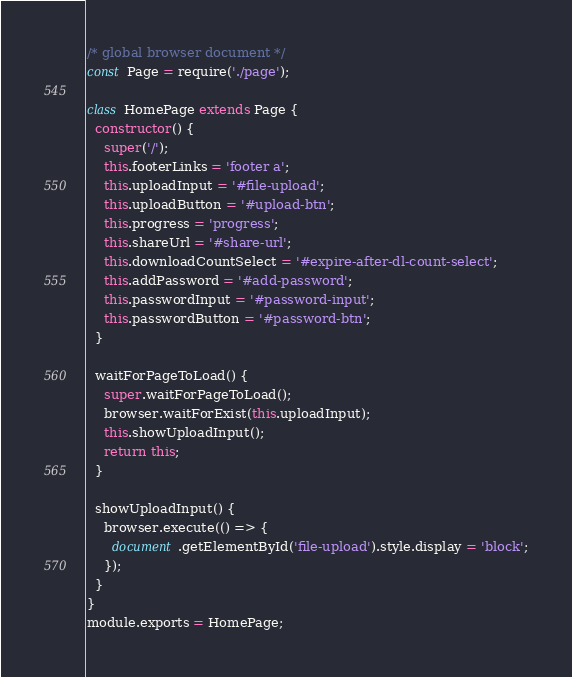<code> <loc_0><loc_0><loc_500><loc_500><_JavaScript_>/* global browser document */
const Page = require('./page');

class HomePage extends Page {
  constructor() {
    super('/');
    this.footerLinks = 'footer a';
    this.uploadInput = '#file-upload';
    this.uploadButton = '#upload-btn';
    this.progress = 'progress';
    this.shareUrl = '#share-url';
    this.downloadCountSelect = '#expire-after-dl-count-select';
    this.addPassword = '#add-password';
    this.passwordInput = '#password-input';
    this.passwordButton = '#password-btn';
  }

  waitForPageToLoad() {
    super.waitForPageToLoad();
    browser.waitForExist(this.uploadInput);
    this.showUploadInput();
    return this;
  }

  showUploadInput() {
    browser.execute(() => {
      document.getElementById('file-upload').style.display = 'block';
    });
  }
}
module.exports = HomePage;
</code> 